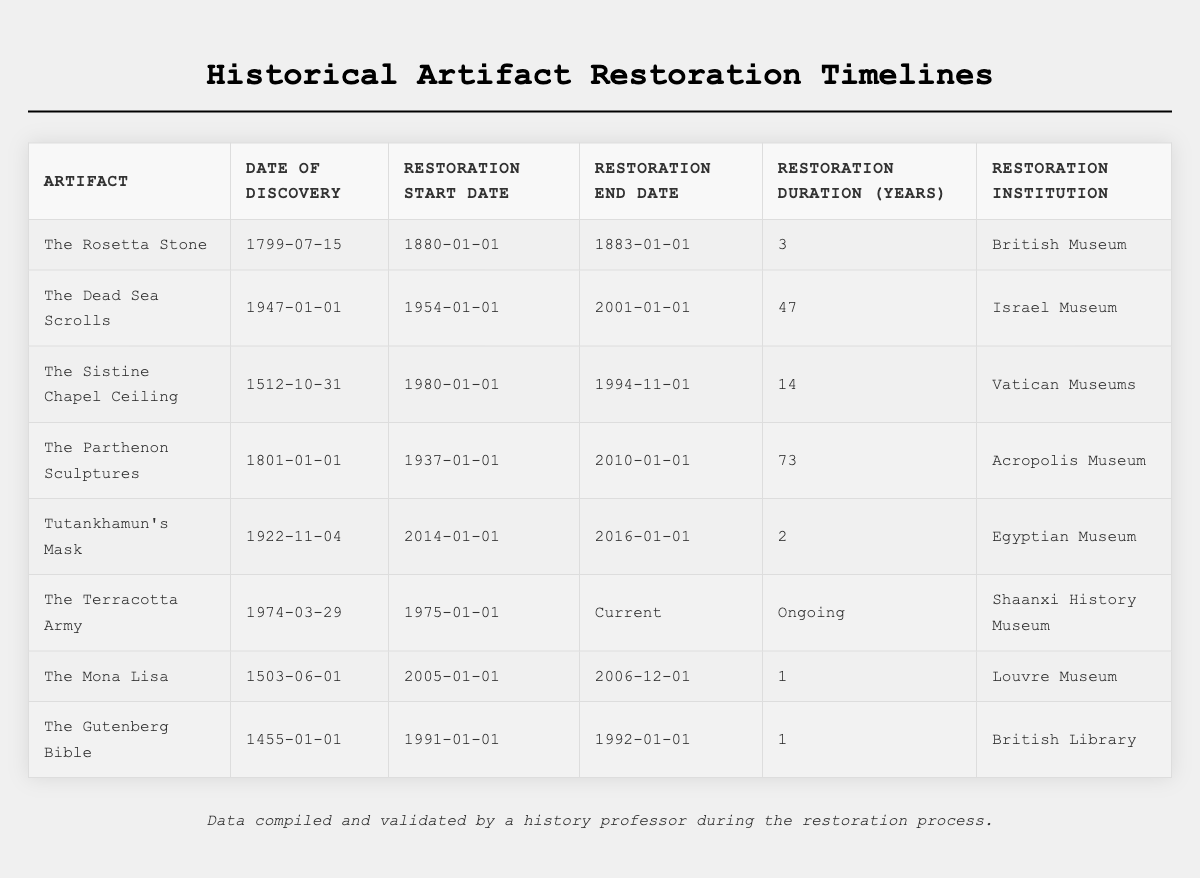What is the restoration duration for The Mona Lisa? The restoration duration is explicitly listed in the table under "Restoration Duration (Years)" for The Mona Lisa, which indicates it lasted for 1 year.
Answer: 1 year Which artifact has the longest restoration duration? By examining the "Restoration Duration (Years)" column, The Parthenon Sculptures shows the longest duration of 73 years.
Answer: The Parthenon Sculptures Did The Rosetta Stone have a restoration duration longer than Tutankhamun's Mask? The Rosetta Stone's restoration duration is 3 years, whereas Tutankhamun's Mask's duration is 2 years; therefore, The Rosetta Stone had a longer duration.
Answer: Yes What year did the restoration of The Sistine Chapel Ceiling begin? The table specifies that the restoration started on January 1, 1980, for The Sistine Chapel Ceiling.
Answer: 1980 Which restoration institution worked on the Dead Sea Scrolls? The table lists the Israel Museum as the restoration institution for the Dead Sea Scrolls.
Answer: Israel Museum How many years were spent restoring The Parthenon Sculptures between its start and end dates? The restoration started on January 1, 1937, and ended on January 1, 2010. To calculate: 2010 - 1937 = 73 years.
Answer: 73 years Is the restoration of The Terracotta Army complete? The table shows the restoration duration as "Ongoing," meaning it has not been completed yet.
Answer: No What is the difference in restoration duration between The Sistine Chapel Ceiling and The Gutenberg Bible? The Sistine Chapel Ceiling took 14 years, while The Gutenberg Bible took 1 year. Therefore, the difference is 14 - 1 = 13 years.
Answer: 13 years Which artifact was restored by the British Museum? The Rosetta Stone is listed under the “Restoration Institution” column associated with the British Museum.
Answer: The Rosetta Stone What was the restoration duration of all artifacts combined? Summing the durations: 3 + 47 + 14 + 73 + 2 + ongoing (not counted) + 1 + 1 = 141 years. There is no need to include the ongoing project's time since it is not complete.
Answer: 141 years Which artifact has a restoration duration shorter than 3 years? By checking the durations listed, only The Mona Lisa and The Gutenberg Bible had restoration durations of 1 year, which is less than 3 years.
Answer: The Mona Lisa and The Gutenberg Bible 